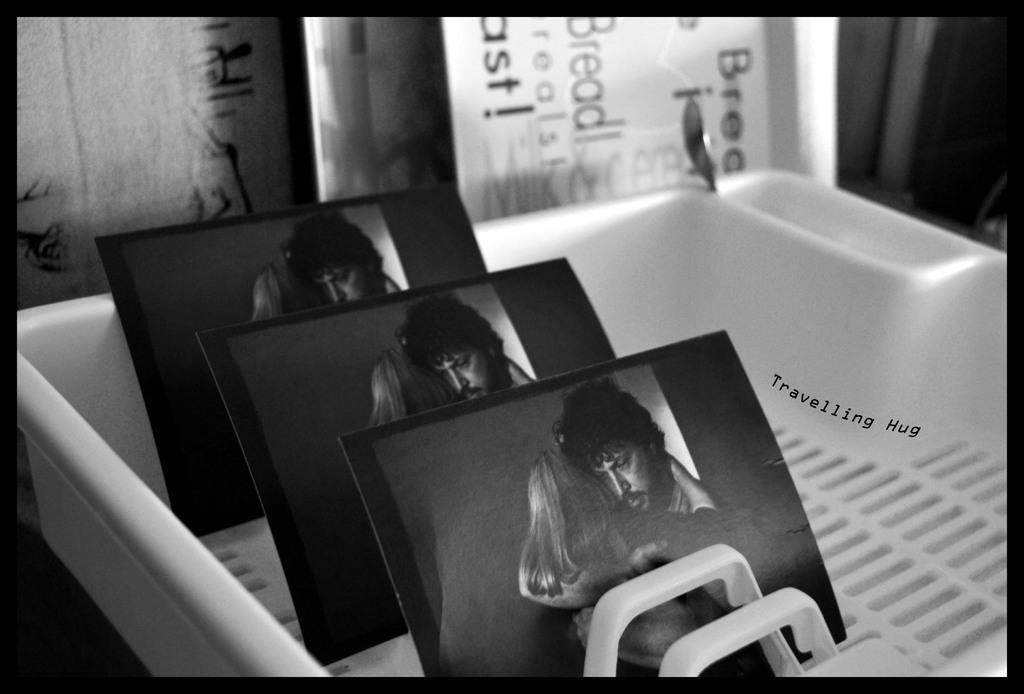What type of image is being shown? The image is an edited picture. What can be seen in the tray in the image? There are photos in a tray, and there is text on the tray. How many people are in the photos? There are two persons in the photos. What is visible at the back of the image? There are boards visible at the back of the image. What type of meat is being cooked on the boards in the image? There is no meat or cooking activity visible in the image; the boards are simply part of the background. Can you tell me how many shoes are present in the image? There are no shoes visible in the image. 